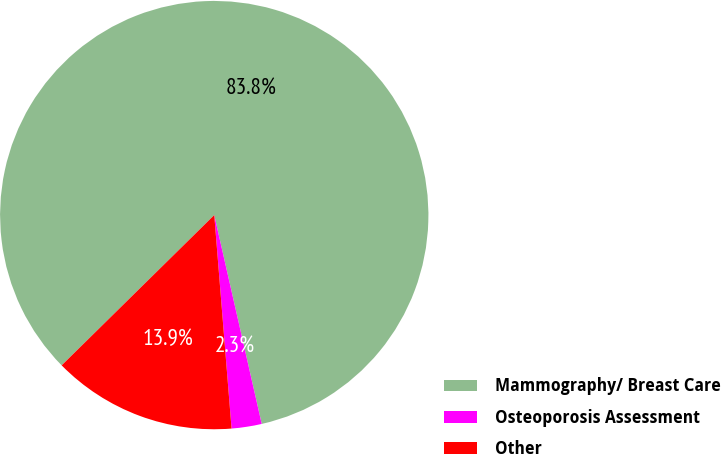Convert chart to OTSL. <chart><loc_0><loc_0><loc_500><loc_500><pie_chart><fcel>Mammography/ Breast Care<fcel>Osteoporosis Assessment<fcel>Other<nl><fcel>83.82%<fcel>2.27%<fcel>13.91%<nl></chart> 